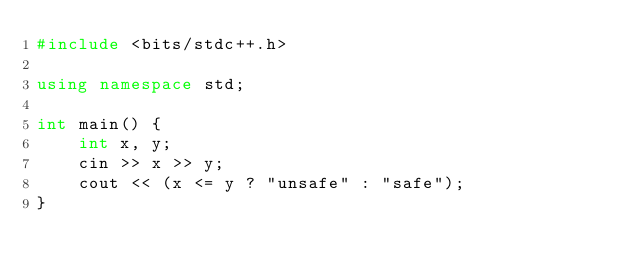Convert code to text. <code><loc_0><loc_0><loc_500><loc_500><_C++_>#include <bits/stdc++.h>

using namespace std;

int main() {
    int x, y;
    cin >> x >> y;
    cout << (x <= y ? "unsafe" : "safe");
}
</code> 